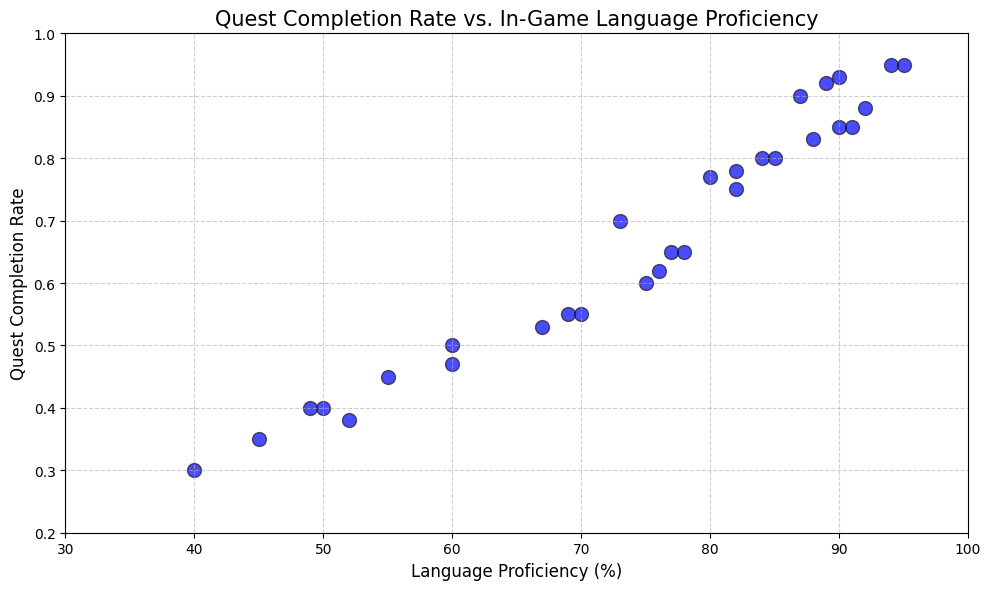What is the relationship between language proficiency and quest completion rate? By looking at the scatter plot, we can observe a positive trend where players with higher language proficiency tend to have higher quest completion rates. This suggests a correlation between the two variables.
Answer: Positive correlation Are there any players with a language proficiency of 90% or higher who have a quest completion rate below 0.8? By examining the plot points, we can see that all players with a language proficiency of 90% or higher have quest completion rates above 0.8.
Answer: No What is the quest completion rate for players with the top three highest language proficiency scores? We identify the top three highest language proficiency scores (95, 94, and 92). The quest completion rates corresponding to these scores are 0.95, 0.95, and 0.88 respectively.
Answer: 0.95, 0.95, 0.88 Does any player with a language proficiency below 50% have a quest completion rate above 0.5? By checking the scatter plot, we see that all players with a language proficiency below 50% have quest completion rates below or equal to 0.5.
Answer: No What is the median quest completion rate for players with a language proficiency between 70% and 80%? First, identify the quest completion rates for players within the 70%-80% language proficiency range (0.60, 0.77, 0.65, 0.62, 0.75, 0.55, 0.78, 0.65). Then, order these rates (0.55, 0.60, 0.62, 0.65, 0.65, 0.75, 0.77, 0.78) and find the median, which is the average of the two middle values: (0.65 + 0.65)/2.
Answer: 0.65 Compare the highest quest completion rate in the dataset with the lowest language proficiency rate. Which one is higher? The highest quest completion rate in the dataset is 0.95, and the lowest language proficiency rate is 40%. Comparing these, 0.95 (quest completion rate) is numerically higher than 40% (language proficiency rate).
Answer: Quest completion rate How many players have a quest completion rate of 0.8 or higher? By counting the number of plot points where the quest completion rate is 0.8 or higher, we find that there are 12 such players.
Answer: 12 What is the approximate quest completion rate for a player with a language proficiency of 85%? Looking at the scatter plot, a point at language proficiency of 85% corresponds approximately to a quest completion rate of 0.8.
Answer: 0.8 Which player has the lowest quest completion rate, and what is their language proficiency? The lowest quest completion rate in the scatter plot corresponds to a value of 0.30. The language proficiency of this player is 40%.
Answer: Player with 40% language proficiency 